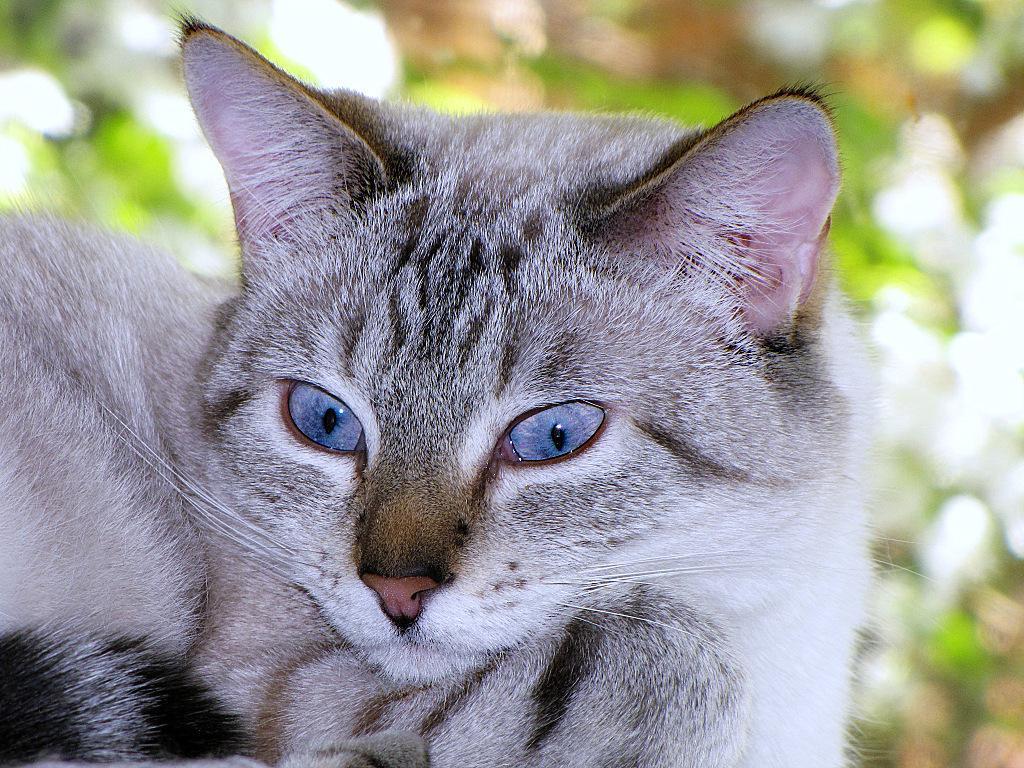Can you describe this image briefly? In the center of the image there is a cat. The background of the image is blurry. 